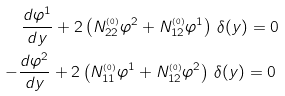<formula> <loc_0><loc_0><loc_500><loc_500>\frac { d \varphi ^ { 1 } } { d y } + 2 \left ( N ^ { _ { ( 0 ) } } _ { 2 2 } \varphi ^ { 2 } + N ^ { _ { ( 0 ) } } _ { 1 2 } \varphi ^ { 1 } \right ) \, \delta ( y ) = 0 \\ - \frac { d \varphi ^ { 2 } } { d y } + 2 \left ( N ^ { _ { ( 0 ) } } _ { 1 1 } \varphi ^ { 1 } + N ^ { _ { ( 0 ) } } _ { 1 2 } \varphi ^ { 2 } \right ) \, \delta ( y ) = 0 \,</formula> 